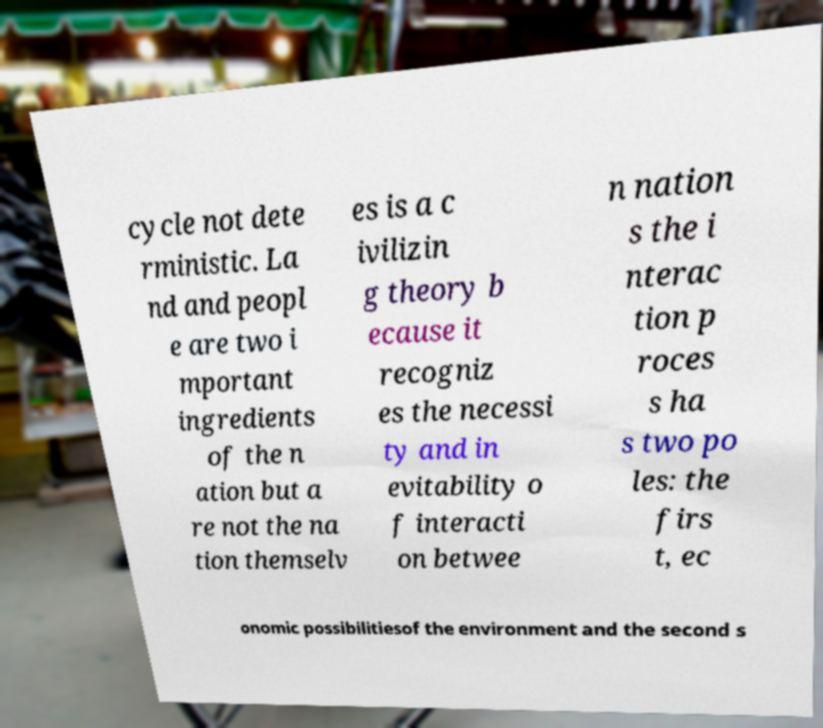Can you accurately transcribe the text from the provided image for me? cycle not dete rministic. La nd and peopl e are two i mportant ingredients of the n ation but a re not the na tion themselv es is a c ivilizin g theory b ecause it recogniz es the necessi ty and in evitability o f interacti on betwee n nation s the i nterac tion p roces s ha s two po les: the firs t, ec onomic possibilitiesof the environment and the second s 